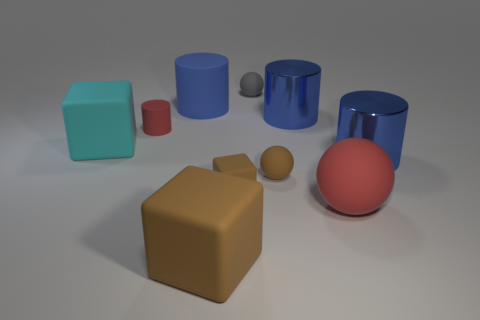Subtract all large matte cylinders. How many cylinders are left? 3 Subtract 1 balls. How many balls are left? 2 Subtract all spheres. How many objects are left? 7 Subtract all brown balls. Subtract all cyan blocks. How many balls are left? 2 Subtract all purple blocks. How many gray cylinders are left? 0 Subtract all large rubber blocks. Subtract all red things. How many objects are left? 6 Add 6 big blue rubber cylinders. How many big blue rubber cylinders are left? 7 Add 4 brown rubber objects. How many brown rubber objects exist? 7 Subtract all gray balls. How many balls are left? 2 Subtract 1 red spheres. How many objects are left? 9 